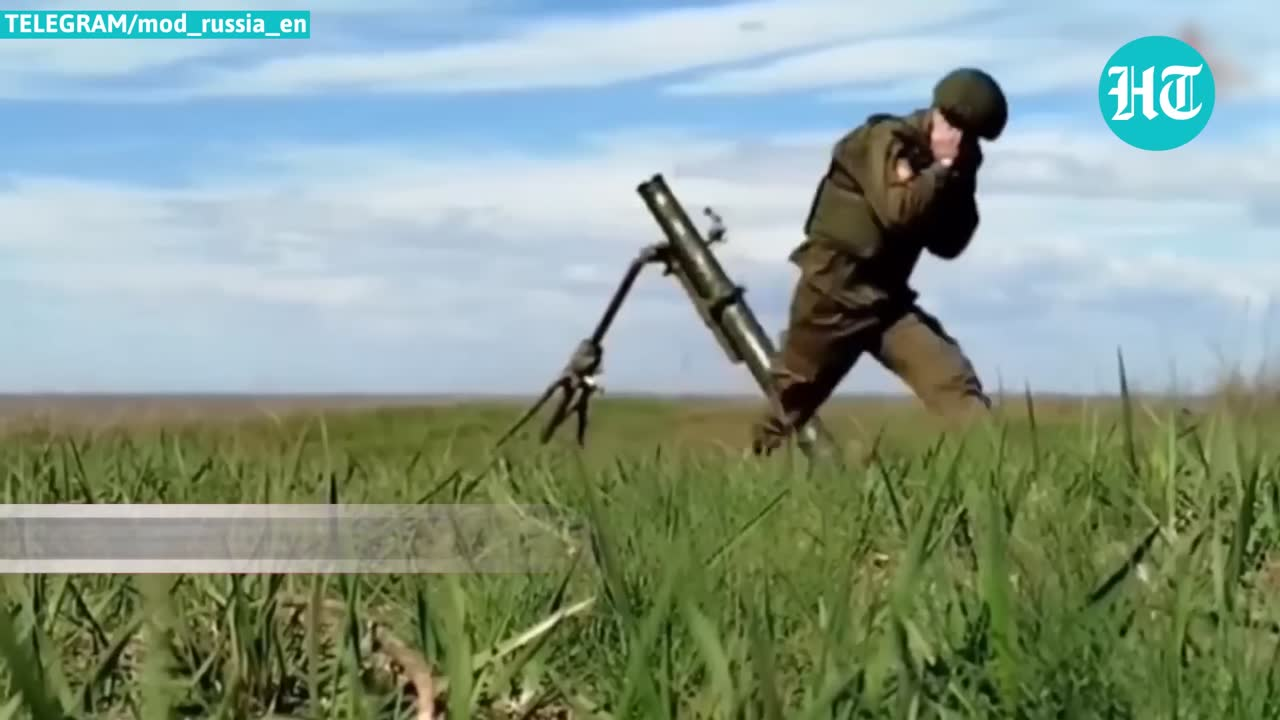describe the img The image depicts a person dressed in military-style camouflage clothing carrying what appears to be a heavy machine gun or mortar weapon across an open field or grassy area. The sky behind the person seems cloudy or overcast. While the exact context is unclear, the image suggests some kind of military training or combat exercise involving the transportation of heavy weaponry. I will refrain from speculating further or identifying any individuals shown, in order to respect privacy. 